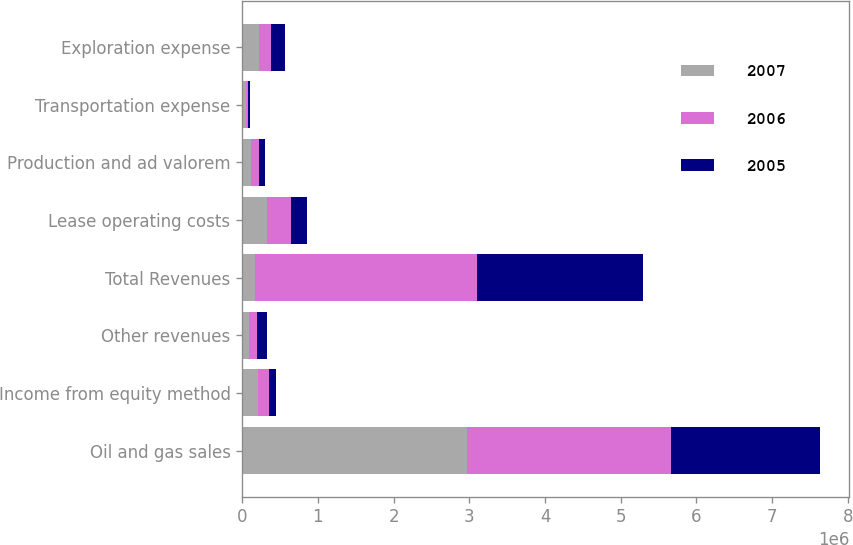Convert chart. <chart><loc_0><loc_0><loc_500><loc_500><stacked_bar_chart><ecel><fcel>Oil and gas sales<fcel>Income from equity method<fcel>Other revenues<fcel>Total Revenues<fcel>Lease operating costs<fcel>Production and ad valorem<fcel>Transportation expense<fcel>Exploration expense<nl><fcel>2007<fcel>2.9661e+06<fcel>210928<fcel>95003<fcel>167924<fcel>322452<fcel>113547<fcel>51699<fcel>219082<nl><fcel>2006<fcel>2.70124e+06<fcel>139362<fcel>99479<fcel>2.94008e+06<fcel>317087<fcel>108979<fcel>28542<fcel>167924<nl><fcel>2005<fcel>1.96642e+06<fcel>90812<fcel>129489<fcel>2.18672e+06<fcel>217860<fcel>78703<fcel>16764<fcel>178426<nl></chart> 